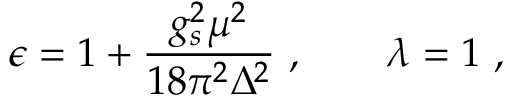Convert formula to latex. <formula><loc_0><loc_0><loc_500><loc_500>\epsilon = 1 + \frac { g _ { s } ^ { 2 } \mu ^ { 2 } } { 1 8 \pi ^ { 2 } \Delta ^ { 2 } } \ , \quad \lambda = 1 \ ,</formula> 